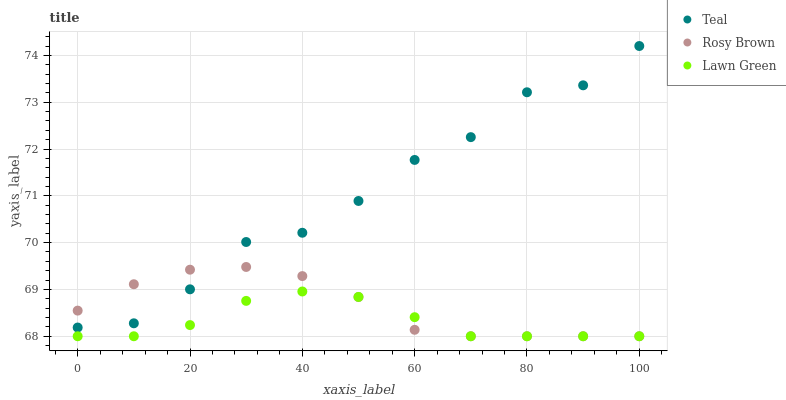Does Lawn Green have the minimum area under the curve?
Answer yes or no. Yes. Does Teal have the maximum area under the curve?
Answer yes or no. Yes. Does Rosy Brown have the minimum area under the curve?
Answer yes or no. No. Does Rosy Brown have the maximum area under the curve?
Answer yes or no. No. Is Lawn Green the smoothest?
Answer yes or no. Yes. Is Teal the roughest?
Answer yes or no. Yes. Is Rosy Brown the smoothest?
Answer yes or no. No. Is Rosy Brown the roughest?
Answer yes or no. No. Does Lawn Green have the lowest value?
Answer yes or no. Yes. Does Teal have the lowest value?
Answer yes or no. No. Does Teal have the highest value?
Answer yes or no. Yes. Does Rosy Brown have the highest value?
Answer yes or no. No. Is Lawn Green less than Teal?
Answer yes or no. Yes. Is Teal greater than Lawn Green?
Answer yes or no. Yes. Does Teal intersect Rosy Brown?
Answer yes or no. Yes. Is Teal less than Rosy Brown?
Answer yes or no. No. Is Teal greater than Rosy Brown?
Answer yes or no. No. Does Lawn Green intersect Teal?
Answer yes or no. No. 